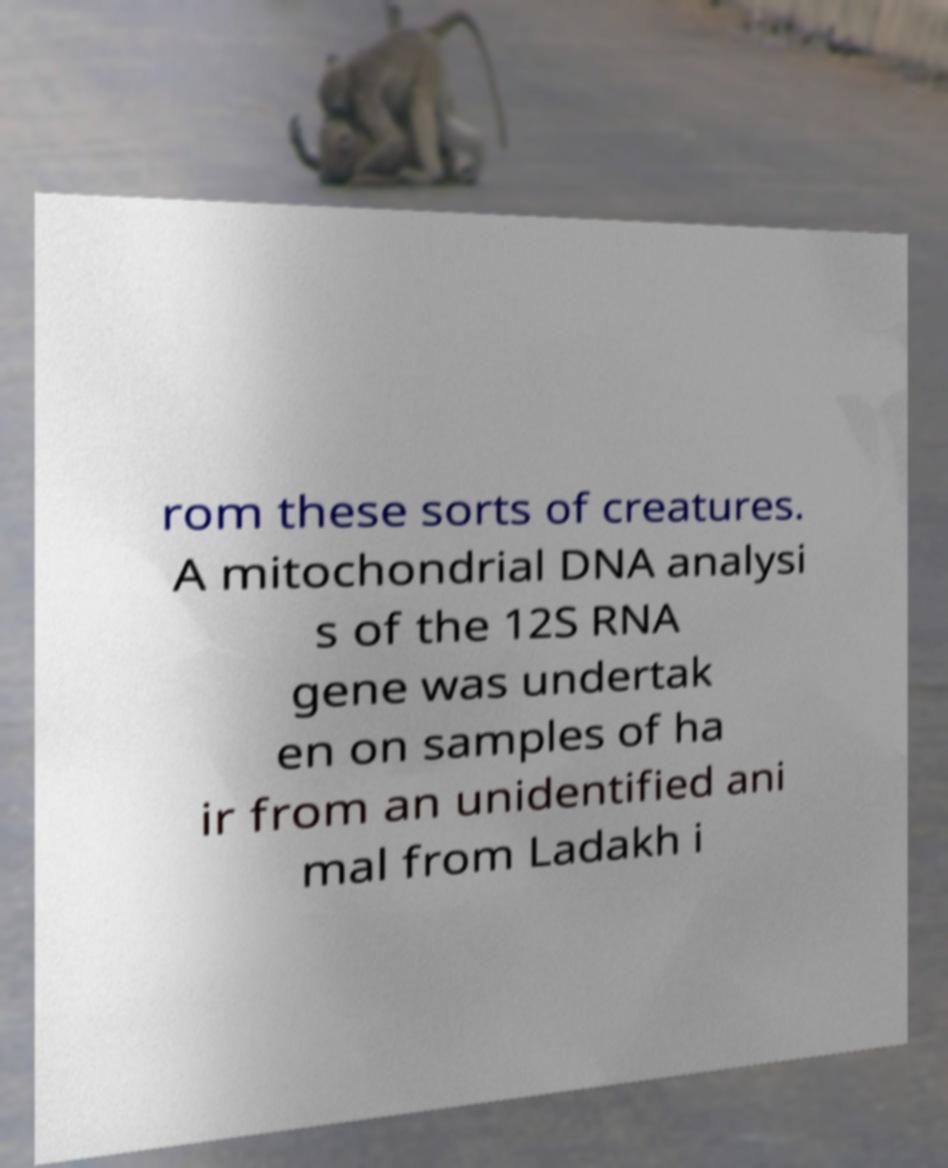Can you accurately transcribe the text from the provided image for me? rom these sorts of creatures. A mitochondrial DNA analysi s of the 12S RNA gene was undertak en on samples of ha ir from an unidentified ani mal from Ladakh i 